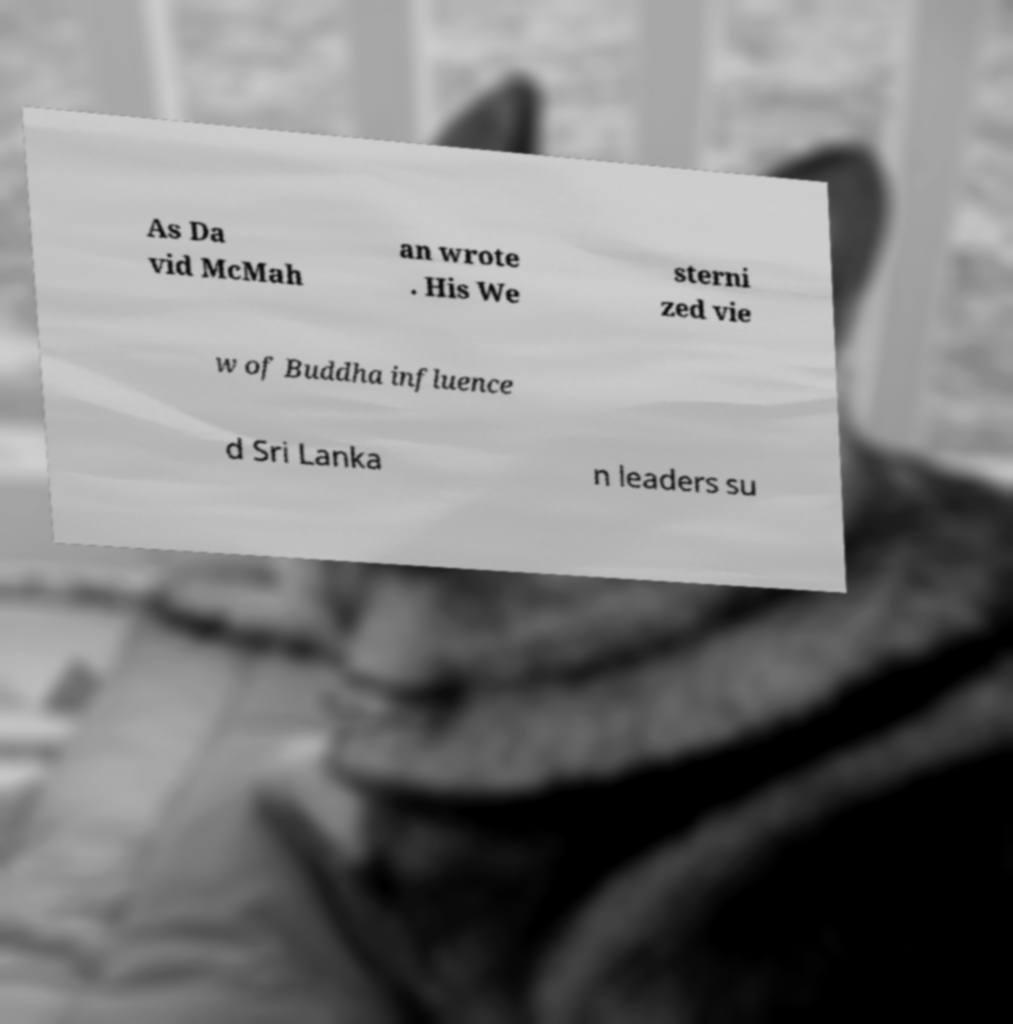Could you extract and type out the text from this image? As Da vid McMah an wrote . His We sterni zed vie w of Buddha influence d Sri Lanka n leaders su 